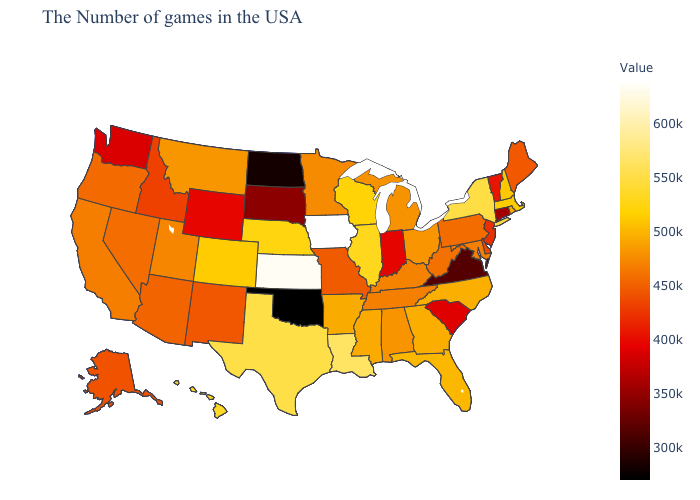Is the legend a continuous bar?
Keep it brief. Yes. Does Iowa have the highest value in the USA?
Concise answer only. Yes. Among the states that border Connecticut , does New York have the lowest value?
Quick response, please. No. Is the legend a continuous bar?
Keep it brief. Yes. Does New York have the highest value in the Northeast?
Give a very brief answer. Yes. 